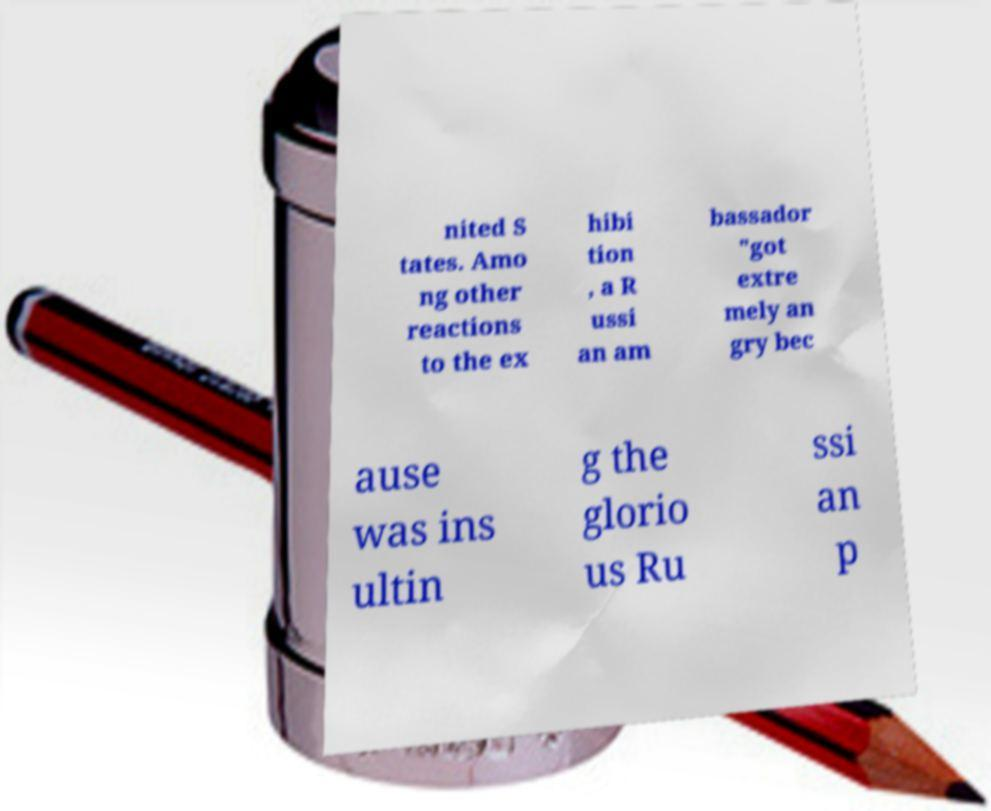Could you extract and type out the text from this image? nited S tates. Amo ng other reactions to the ex hibi tion , a R ussi an am bassador "got extre mely an gry bec ause was ins ultin g the glorio us Ru ssi an p 